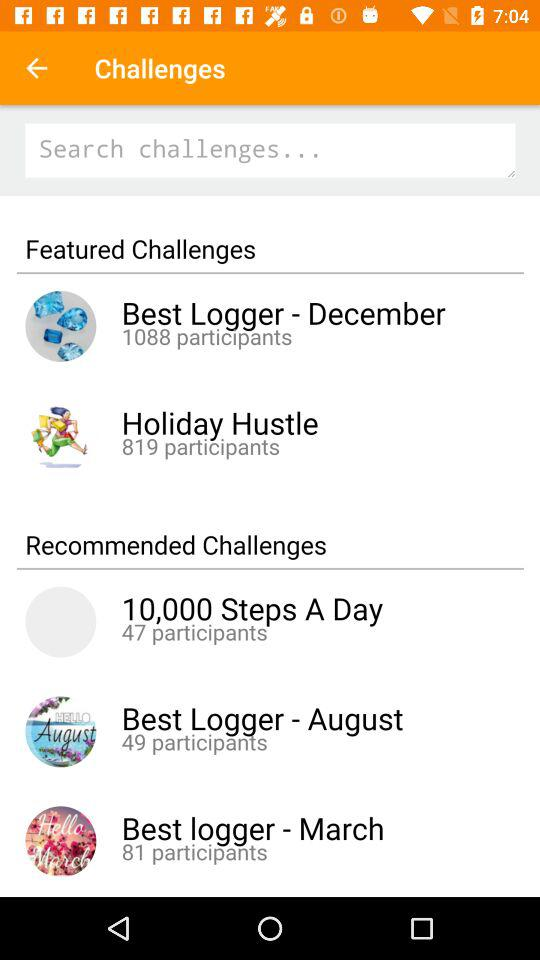How many participants are there in the holiday hustle? There are 819 participants in the holiday hustle. 